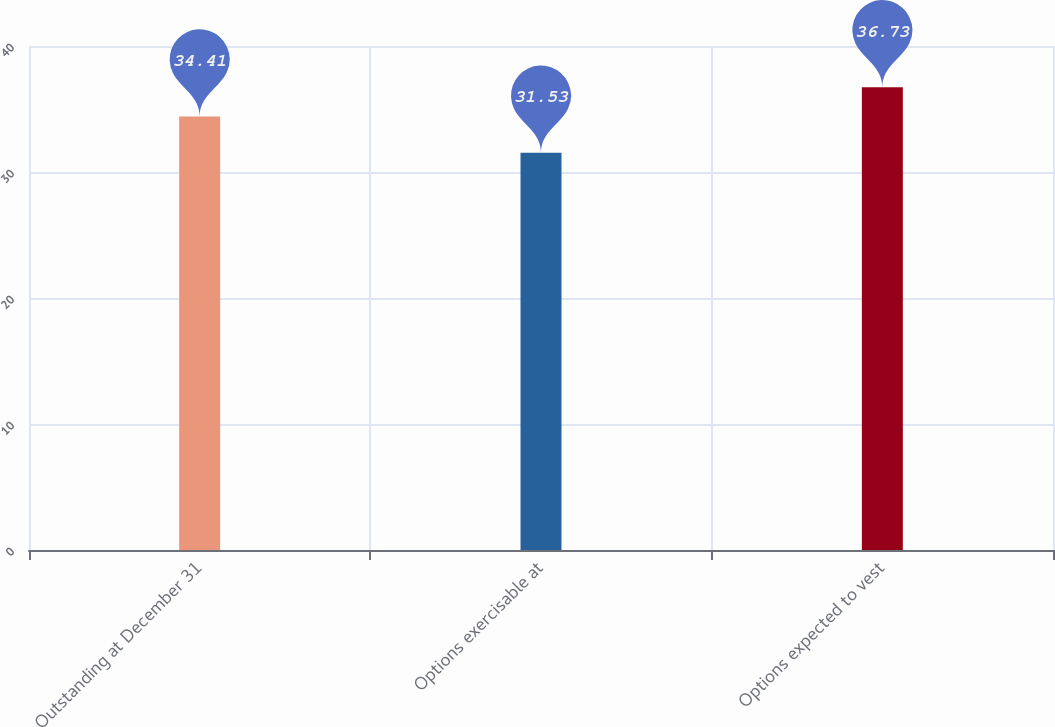Convert chart to OTSL. <chart><loc_0><loc_0><loc_500><loc_500><bar_chart><fcel>Outstanding at December 31<fcel>Options exercisable at<fcel>Options expected to vest<nl><fcel>34.41<fcel>31.53<fcel>36.73<nl></chart> 